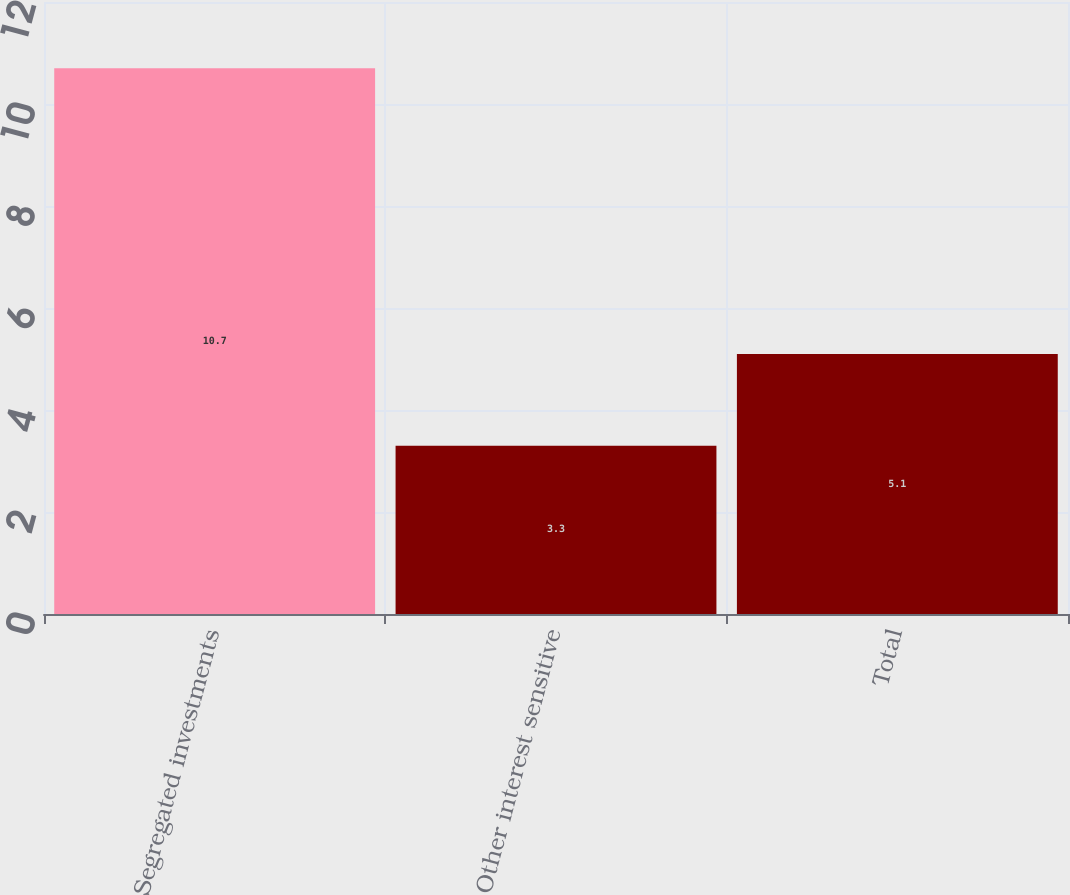Convert chart. <chart><loc_0><loc_0><loc_500><loc_500><bar_chart><fcel>Segregated investments<fcel>Other interest sensitive<fcel>Total<nl><fcel>10.7<fcel>3.3<fcel>5.1<nl></chart> 